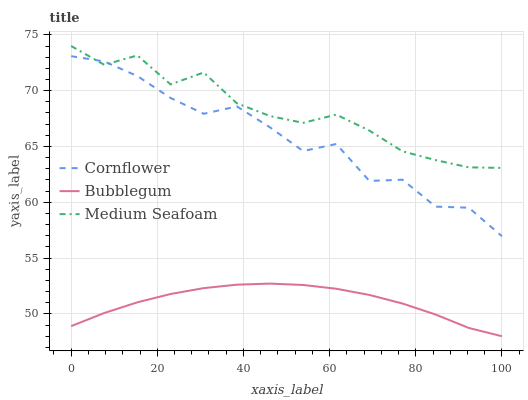Does Bubblegum have the minimum area under the curve?
Answer yes or no. Yes. Does Medium Seafoam have the maximum area under the curve?
Answer yes or no. Yes. Does Medium Seafoam have the minimum area under the curve?
Answer yes or no. No. Does Bubblegum have the maximum area under the curve?
Answer yes or no. No. Is Bubblegum the smoothest?
Answer yes or no. Yes. Is Cornflower the roughest?
Answer yes or no. Yes. Is Medium Seafoam the smoothest?
Answer yes or no. No. Is Medium Seafoam the roughest?
Answer yes or no. No. Does Bubblegum have the lowest value?
Answer yes or no. Yes. Does Medium Seafoam have the lowest value?
Answer yes or no. No. Does Medium Seafoam have the highest value?
Answer yes or no. Yes. Does Bubblegum have the highest value?
Answer yes or no. No. Is Bubblegum less than Cornflower?
Answer yes or no. Yes. Is Cornflower greater than Bubblegum?
Answer yes or no. Yes. Does Medium Seafoam intersect Cornflower?
Answer yes or no. Yes. Is Medium Seafoam less than Cornflower?
Answer yes or no. No. Is Medium Seafoam greater than Cornflower?
Answer yes or no. No. Does Bubblegum intersect Cornflower?
Answer yes or no. No. 